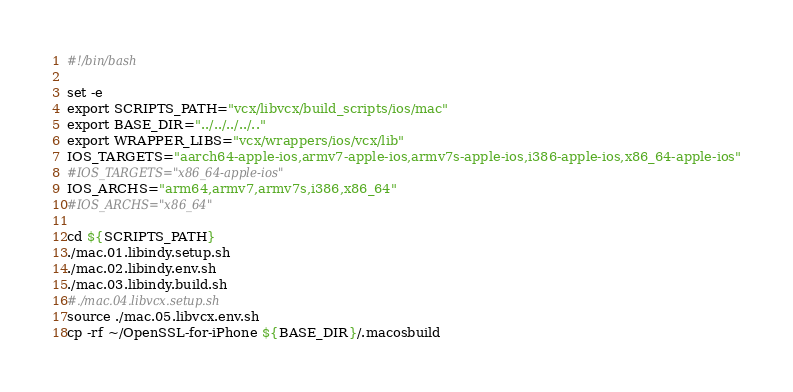Convert code to text. <code><loc_0><loc_0><loc_500><loc_500><_Bash_>#!/bin/bash

set -e
export SCRIPTS_PATH="vcx/libvcx/build_scripts/ios/mac"
export BASE_DIR="../../../../.."
export WRAPPER_LIBS="vcx/wrappers/ios/vcx/lib"
IOS_TARGETS="aarch64-apple-ios,armv7-apple-ios,armv7s-apple-ios,i386-apple-ios,x86_64-apple-ios"
#IOS_TARGETS="x86_64-apple-ios"
IOS_ARCHS="arm64,armv7,armv7s,i386,x86_64"
#IOS_ARCHS="x86_64"

cd ${SCRIPTS_PATH}
./mac.01.libindy.setup.sh
./mac.02.libindy.env.sh
./mac.03.libindy.build.sh
#./mac.04.libvcx.setup.sh
source ./mac.05.libvcx.env.sh
cp -rf ~/OpenSSL-for-iPhone ${BASE_DIR}/.macosbuild</code> 